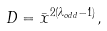Convert formula to latex. <formula><loc_0><loc_0><loc_500><loc_500>D = \bar { x } ^ { 2 ( \lambda _ { o d d } - 1 ) } ,</formula> 